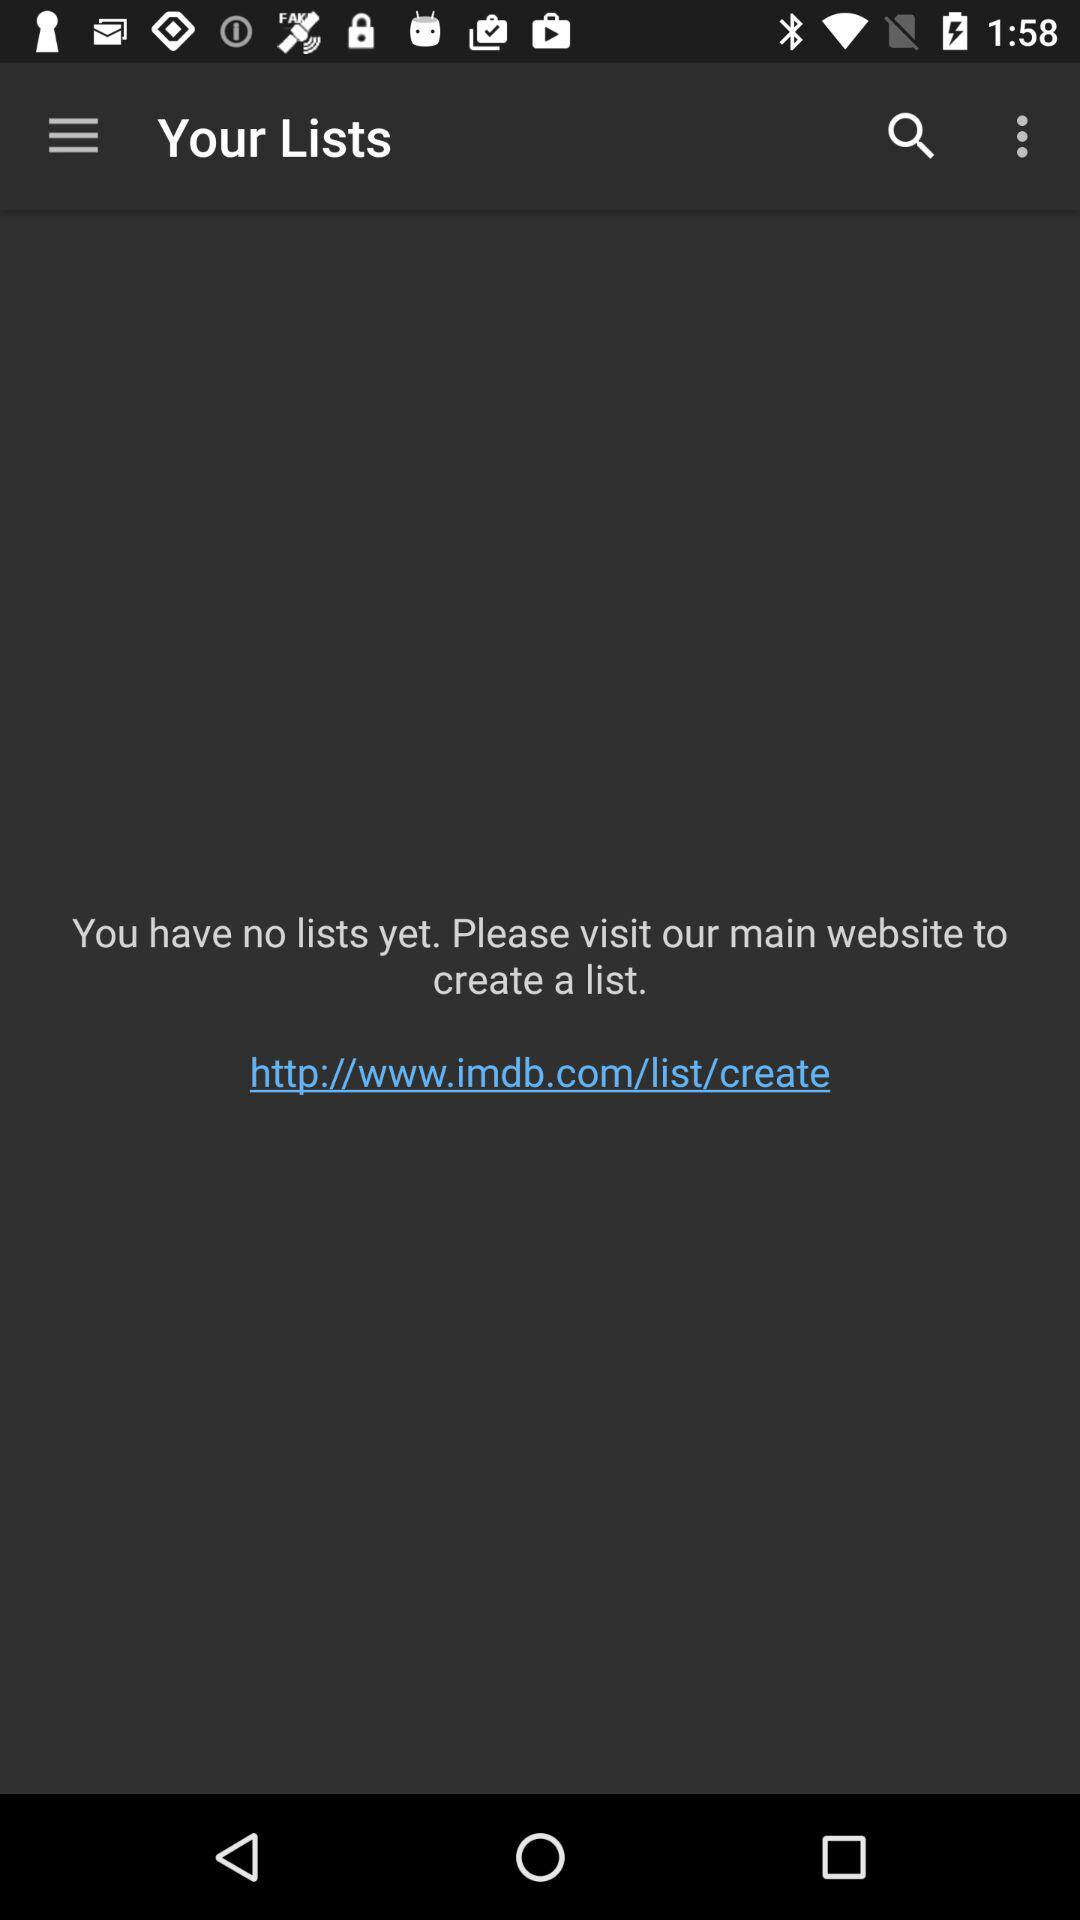What is the link to the website to create a list? The link to the website is http://www.imdb.com/list/create. 